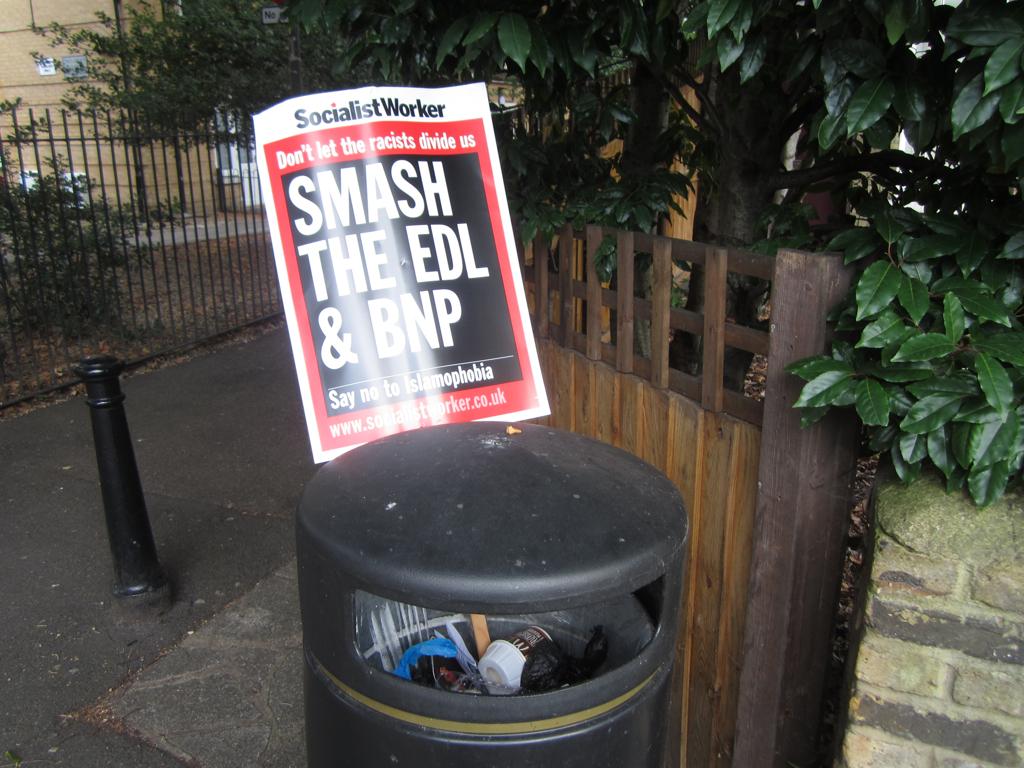What is the top line?
Ensure brevity in your answer.  Socialist worker. 